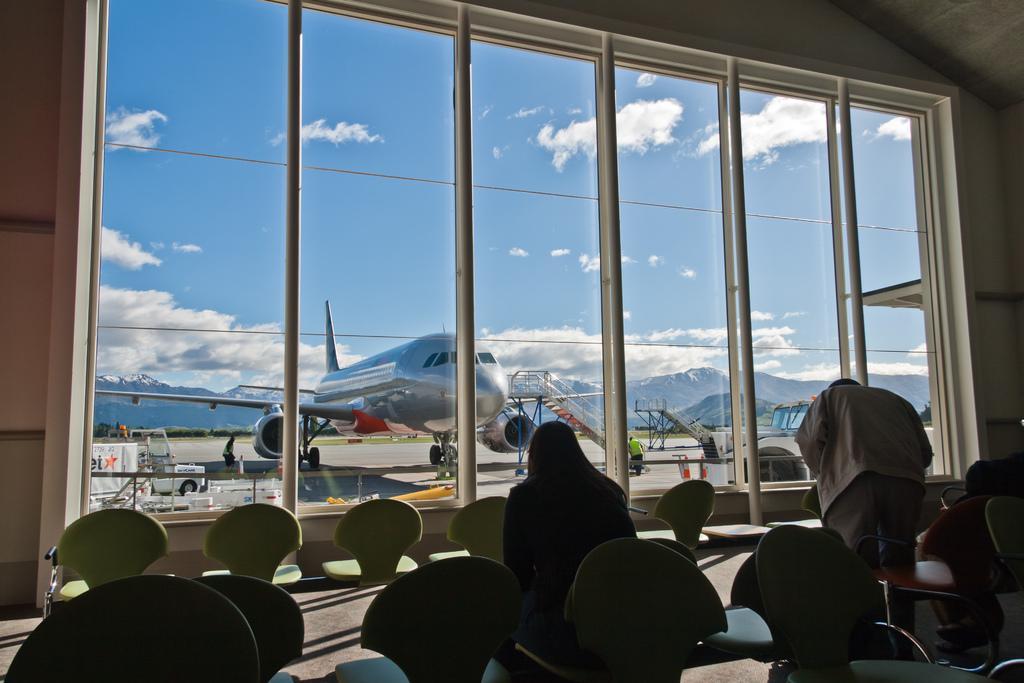In one or two sentences, can you explain what this image depicts? In this image there is an airplane and few vehicles on the runway. Few persons are standing on the runway. Behind plane there are few hills. Top of image there is sky with some clouds. Front side of image there are few chairs having few persons are sitting on it. A person is standing on the floor. In front of them there is a window to the wall. 